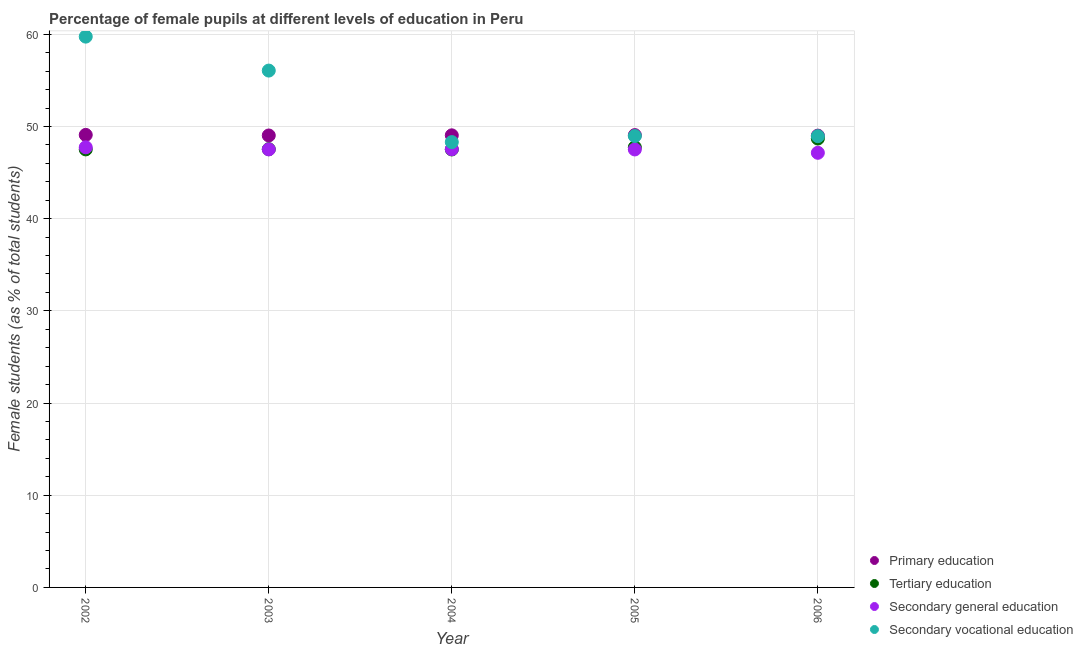What is the percentage of female students in secondary vocational education in 2004?
Give a very brief answer. 48.3. Across all years, what is the maximum percentage of female students in secondary vocational education?
Offer a terse response. 59.74. Across all years, what is the minimum percentage of female students in primary education?
Your answer should be very brief. 49. In which year was the percentage of female students in secondary education maximum?
Your answer should be very brief. 2002. In which year was the percentage of female students in tertiary education minimum?
Your answer should be very brief. 2004. What is the total percentage of female students in tertiary education in the graph?
Offer a terse response. 238.97. What is the difference between the percentage of female students in tertiary education in 2003 and that in 2005?
Ensure brevity in your answer.  -0.21. What is the difference between the percentage of female students in primary education in 2006 and the percentage of female students in secondary education in 2002?
Provide a succinct answer. 1.27. What is the average percentage of female students in secondary vocational education per year?
Offer a very short reply. 52.4. In the year 2004, what is the difference between the percentage of female students in primary education and percentage of female students in secondary vocational education?
Provide a short and direct response. 0.73. In how many years, is the percentage of female students in primary education greater than 22 %?
Your response must be concise. 5. What is the ratio of the percentage of female students in secondary vocational education in 2002 to that in 2003?
Your answer should be very brief. 1.07. What is the difference between the highest and the second highest percentage of female students in tertiary education?
Offer a very short reply. 0.95. What is the difference between the highest and the lowest percentage of female students in secondary vocational education?
Provide a short and direct response. 11.44. Is it the case that in every year, the sum of the percentage of female students in primary education and percentage of female students in secondary vocational education is greater than the sum of percentage of female students in secondary education and percentage of female students in tertiary education?
Give a very brief answer. No. Does the percentage of female students in primary education monotonically increase over the years?
Your response must be concise. No. How many years are there in the graph?
Your answer should be very brief. 5. What is the difference between two consecutive major ticks on the Y-axis?
Ensure brevity in your answer.  10. Does the graph contain grids?
Provide a short and direct response. Yes. Where does the legend appear in the graph?
Ensure brevity in your answer.  Bottom right. What is the title of the graph?
Your response must be concise. Percentage of female pupils at different levels of education in Peru. What is the label or title of the X-axis?
Make the answer very short. Year. What is the label or title of the Y-axis?
Your answer should be compact. Female students (as % of total students). What is the Female students (as % of total students) of Primary education in 2002?
Offer a terse response. 49.08. What is the Female students (as % of total students) of Tertiary education in 2002?
Your response must be concise. 47.51. What is the Female students (as % of total students) of Secondary general education in 2002?
Offer a terse response. 47.74. What is the Female students (as % of total students) in Secondary vocational education in 2002?
Offer a very short reply. 59.74. What is the Female students (as % of total students) of Primary education in 2003?
Your answer should be compact. 49.02. What is the Female students (as % of total students) of Tertiary education in 2003?
Ensure brevity in your answer.  47.53. What is the Female students (as % of total students) in Secondary general education in 2003?
Make the answer very short. 47.51. What is the Female students (as % of total students) in Secondary vocational education in 2003?
Offer a terse response. 56.06. What is the Female students (as % of total students) of Primary education in 2004?
Ensure brevity in your answer.  49.04. What is the Female students (as % of total students) of Tertiary education in 2004?
Offer a very short reply. 47.5. What is the Female students (as % of total students) of Secondary general education in 2004?
Provide a succinct answer. 47.53. What is the Female students (as % of total students) in Secondary vocational education in 2004?
Your answer should be compact. 48.3. What is the Female students (as % of total students) of Primary education in 2005?
Ensure brevity in your answer.  49.06. What is the Female students (as % of total students) in Tertiary education in 2005?
Your answer should be very brief. 47.74. What is the Female students (as % of total students) of Secondary general education in 2005?
Your response must be concise. 47.5. What is the Female students (as % of total students) in Secondary vocational education in 2005?
Your answer should be very brief. 48.96. What is the Female students (as % of total students) in Primary education in 2006?
Offer a very short reply. 49. What is the Female students (as % of total students) in Tertiary education in 2006?
Provide a short and direct response. 48.69. What is the Female students (as % of total students) in Secondary general education in 2006?
Offer a terse response. 47.14. What is the Female students (as % of total students) of Secondary vocational education in 2006?
Offer a very short reply. 48.94. Across all years, what is the maximum Female students (as % of total students) in Primary education?
Your response must be concise. 49.08. Across all years, what is the maximum Female students (as % of total students) in Tertiary education?
Provide a short and direct response. 48.69. Across all years, what is the maximum Female students (as % of total students) in Secondary general education?
Give a very brief answer. 47.74. Across all years, what is the maximum Female students (as % of total students) in Secondary vocational education?
Your response must be concise. 59.74. Across all years, what is the minimum Female students (as % of total students) of Primary education?
Your answer should be very brief. 49. Across all years, what is the minimum Female students (as % of total students) in Tertiary education?
Give a very brief answer. 47.5. Across all years, what is the minimum Female students (as % of total students) in Secondary general education?
Offer a very short reply. 47.14. Across all years, what is the minimum Female students (as % of total students) of Secondary vocational education?
Keep it short and to the point. 48.3. What is the total Female students (as % of total students) of Primary education in the graph?
Provide a succinct answer. 245.2. What is the total Female students (as % of total students) in Tertiary education in the graph?
Ensure brevity in your answer.  238.97. What is the total Female students (as % of total students) in Secondary general education in the graph?
Offer a terse response. 237.43. What is the total Female students (as % of total students) in Secondary vocational education in the graph?
Offer a very short reply. 262.01. What is the difference between the Female students (as % of total students) in Primary education in 2002 and that in 2003?
Your answer should be very brief. 0.06. What is the difference between the Female students (as % of total students) in Tertiary education in 2002 and that in 2003?
Offer a very short reply. -0.02. What is the difference between the Female students (as % of total students) of Secondary general education in 2002 and that in 2003?
Offer a terse response. 0.23. What is the difference between the Female students (as % of total students) in Secondary vocational education in 2002 and that in 2003?
Provide a short and direct response. 3.68. What is the difference between the Female students (as % of total students) in Primary education in 2002 and that in 2004?
Provide a short and direct response. 0.05. What is the difference between the Female students (as % of total students) in Tertiary education in 2002 and that in 2004?
Your answer should be compact. 0.01. What is the difference between the Female students (as % of total students) of Secondary general education in 2002 and that in 2004?
Your answer should be very brief. 0.21. What is the difference between the Female students (as % of total students) in Secondary vocational education in 2002 and that in 2004?
Your answer should be compact. 11.44. What is the difference between the Female students (as % of total students) of Primary education in 2002 and that in 2005?
Provide a short and direct response. 0.02. What is the difference between the Female students (as % of total students) in Tertiary education in 2002 and that in 2005?
Offer a very short reply. -0.23. What is the difference between the Female students (as % of total students) in Secondary general education in 2002 and that in 2005?
Make the answer very short. 0.23. What is the difference between the Female students (as % of total students) of Secondary vocational education in 2002 and that in 2005?
Make the answer very short. 10.78. What is the difference between the Female students (as % of total students) of Primary education in 2002 and that in 2006?
Keep it short and to the point. 0.08. What is the difference between the Female students (as % of total students) in Tertiary education in 2002 and that in 2006?
Offer a terse response. -1.18. What is the difference between the Female students (as % of total students) in Secondary general education in 2002 and that in 2006?
Your response must be concise. 0.6. What is the difference between the Female students (as % of total students) of Secondary vocational education in 2002 and that in 2006?
Provide a short and direct response. 10.8. What is the difference between the Female students (as % of total students) of Primary education in 2003 and that in 2004?
Your answer should be very brief. -0.02. What is the difference between the Female students (as % of total students) of Tertiary education in 2003 and that in 2004?
Give a very brief answer. 0.03. What is the difference between the Female students (as % of total students) in Secondary general education in 2003 and that in 2004?
Make the answer very short. -0.02. What is the difference between the Female students (as % of total students) of Secondary vocational education in 2003 and that in 2004?
Offer a terse response. 7.76. What is the difference between the Female students (as % of total students) of Primary education in 2003 and that in 2005?
Make the answer very short. -0.04. What is the difference between the Female students (as % of total students) in Tertiary education in 2003 and that in 2005?
Your answer should be very brief. -0.21. What is the difference between the Female students (as % of total students) of Secondary general education in 2003 and that in 2005?
Your answer should be very brief. 0.01. What is the difference between the Female students (as % of total students) in Secondary vocational education in 2003 and that in 2005?
Provide a succinct answer. 7.1. What is the difference between the Female students (as % of total students) of Primary education in 2003 and that in 2006?
Your response must be concise. 0.02. What is the difference between the Female students (as % of total students) in Tertiary education in 2003 and that in 2006?
Offer a very short reply. -1.16. What is the difference between the Female students (as % of total students) in Secondary general education in 2003 and that in 2006?
Offer a very short reply. 0.37. What is the difference between the Female students (as % of total students) of Secondary vocational education in 2003 and that in 2006?
Give a very brief answer. 7.12. What is the difference between the Female students (as % of total students) of Primary education in 2004 and that in 2005?
Offer a terse response. -0.02. What is the difference between the Female students (as % of total students) of Tertiary education in 2004 and that in 2005?
Your answer should be very brief. -0.23. What is the difference between the Female students (as % of total students) of Secondary general education in 2004 and that in 2005?
Your answer should be very brief. 0.03. What is the difference between the Female students (as % of total students) of Secondary vocational education in 2004 and that in 2005?
Your response must be concise. -0.66. What is the difference between the Female students (as % of total students) in Primary education in 2004 and that in 2006?
Offer a terse response. 0.03. What is the difference between the Female students (as % of total students) in Tertiary education in 2004 and that in 2006?
Provide a short and direct response. -1.18. What is the difference between the Female students (as % of total students) of Secondary general education in 2004 and that in 2006?
Provide a succinct answer. 0.39. What is the difference between the Female students (as % of total students) in Secondary vocational education in 2004 and that in 2006?
Make the answer very short. -0.64. What is the difference between the Female students (as % of total students) in Primary education in 2005 and that in 2006?
Offer a very short reply. 0.06. What is the difference between the Female students (as % of total students) of Tertiary education in 2005 and that in 2006?
Make the answer very short. -0.95. What is the difference between the Female students (as % of total students) in Secondary general education in 2005 and that in 2006?
Your answer should be very brief. 0.36. What is the difference between the Female students (as % of total students) of Secondary vocational education in 2005 and that in 2006?
Your response must be concise. 0.02. What is the difference between the Female students (as % of total students) in Primary education in 2002 and the Female students (as % of total students) in Tertiary education in 2003?
Offer a terse response. 1.55. What is the difference between the Female students (as % of total students) of Primary education in 2002 and the Female students (as % of total students) of Secondary general education in 2003?
Your answer should be very brief. 1.57. What is the difference between the Female students (as % of total students) of Primary education in 2002 and the Female students (as % of total students) of Secondary vocational education in 2003?
Provide a short and direct response. -6.98. What is the difference between the Female students (as % of total students) in Tertiary education in 2002 and the Female students (as % of total students) in Secondary vocational education in 2003?
Your answer should be very brief. -8.55. What is the difference between the Female students (as % of total students) in Secondary general education in 2002 and the Female students (as % of total students) in Secondary vocational education in 2003?
Ensure brevity in your answer.  -8.32. What is the difference between the Female students (as % of total students) of Primary education in 2002 and the Female students (as % of total students) of Tertiary education in 2004?
Your response must be concise. 1.58. What is the difference between the Female students (as % of total students) in Primary education in 2002 and the Female students (as % of total students) in Secondary general education in 2004?
Give a very brief answer. 1.55. What is the difference between the Female students (as % of total students) in Primary education in 2002 and the Female students (as % of total students) in Secondary vocational education in 2004?
Offer a very short reply. 0.78. What is the difference between the Female students (as % of total students) in Tertiary education in 2002 and the Female students (as % of total students) in Secondary general education in 2004?
Offer a terse response. -0.02. What is the difference between the Female students (as % of total students) of Tertiary education in 2002 and the Female students (as % of total students) of Secondary vocational education in 2004?
Provide a succinct answer. -0.79. What is the difference between the Female students (as % of total students) in Secondary general education in 2002 and the Female students (as % of total students) in Secondary vocational education in 2004?
Ensure brevity in your answer.  -0.56. What is the difference between the Female students (as % of total students) of Primary education in 2002 and the Female students (as % of total students) of Tertiary education in 2005?
Your answer should be very brief. 1.35. What is the difference between the Female students (as % of total students) in Primary education in 2002 and the Female students (as % of total students) in Secondary general education in 2005?
Your answer should be compact. 1.58. What is the difference between the Female students (as % of total students) of Primary education in 2002 and the Female students (as % of total students) of Secondary vocational education in 2005?
Your answer should be very brief. 0.12. What is the difference between the Female students (as % of total students) of Tertiary education in 2002 and the Female students (as % of total students) of Secondary general education in 2005?
Your answer should be compact. 0.01. What is the difference between the Female students (as % of total students) of Tertiary education in 2002 and the Female students (as % of total students) of Secondary vocational education in 2005?
Offer a terse response. -1.45. What is the difference between the Female students (as % of total students) of Secondary general education in 2002 and the Female students (as % of total students) of Secondary vocational education in 2005?
Offer a very short reply. -1.22. What is the difference between the Female students (as % of total students) in Primary education in 2002 and the Female students (as % of total students) in Tertiary education in 2006?
Keep it short and to the point. 0.4. What is the difference between the Female students (as % of total students) in Primary education in 2002 and the Female students (as % of total students) in Secondary general education in 2006?
Your answer should be very brief. 1.94. What is the difference between the Female students (as % of total students) in Primary education in 2002 and the Female students (as % of total students) in Secondary vocational education in 2006?
Offer a terse response. 0.14. What is the difference between the Female students (as % of total students) in Tertiary education in 2002 and the Female students (as % of total students) in Secondary general education in 2006?
Offer a very short reply. 0.37. What is the difference between the Female students (as % of total students) in Tertiary education in 2002 and the Female students (as % of total students) in Secondary vocational education in 2006?
Your answer should be compact. -1.43. What is the difference between the Female students (as % of total students) in Secondary general education in 2002 and the Female students (as % of total students) in Secondary vocational education in 2006?
Make the answer very short. -1.21. What is the difference between the Female students (as % of total students) in Primary education in 2003 and the Female students (as % of total students) in Tertiary education in 2004?
Provide a succinct answer. 1.52. What is the difference between the Female students (as % of total students) in Primary education in 2003 and the Female students (as % of total students) in Secondary general education in 2004?
Offer a very short reply. 1.49. What is the difference between the Female students (as % of total students) in Primary education in 2003 and the Female students (as % of total students) in Secondary vocational education in 2004?
Your answer should be very brief. 0.72. What is the difference between the Female students (as % of total students) in Tertiary education in 2003 and the Female students (as % of total students) in Secondary general education in 2004?
Provide a succinct answer. 0. What is the difference between the Female students (as % of total students) of Tertiary education in 2003 and the Female students (as % of total students) of Secondary vocational education in 2004?
Provide a succinct answer. -0.77. What is the difference between the Female students (as % of total students) in Secondary general education in 2003 and the Female students (as % of total students) in Secondary vocational education in 2004?
Provide a short and direct response. -0.79. What is the difference between the Female students (as % of total students) of Primary education in 2003 and the Female students (as % of total students) of Tertiary education in 2005?
Provide a short and direct response. 1.28. What is the difference between the Female students (as % of total students) in Primary education in 2003 and the Female students (as % of total students) in Secondary general education in 2005?
Give a very brief answer. 1.52. What is the difference between the Female students (as % of total students) in Primary education in 2003 and the Female students (as % of total students) in Secondary vocational education in 2005?
Ensure brevity in your answer.  0.06. What is the difference between the Female students (as % of total students) in Tertiary education in 2003 and the Female students (as % of total students) in Secondary general education in 2005?
Make the answer very short. 0.03. What is the difference between the Female students (as % of total students) of Tertiary education in 2003 and the Female students (as % of total students) of Secondary vocational education in 2005?
Your answer should be very brief. -1.43. What is the difference between the Female students (as % of total students) of Secondary general education in 2003 and the Female students (as % of total students) of Secondary vocational education in 2005?
Ensure brevity in your answer.  -1.45. What is the difference between the Female students (as % of total students) in Primary education in 2003 and the Female students (as % of total students) in Tertiary education in 2006?
Give a very brief answer. 0.33. What is the difference between the Female students (as % of total students) in Primary education in 2003 and the Female students (as % of total students) in Secondary general education in 2006?
Make the answer very short. 1.88. What is the difference between the Female students (as % of total students) in Primary education in 2003 and the Female students (as % of total students) in Secondary vocational education in 2006?
Offer a very short reply. 0.08. What is the difference between the Female students (as % of total students) in Tertiary education in 2003 and the Female students (as % of total students) in Secondary general education in 2006?
Offer a terse response. 0.39. What is the difference between the Female students (as % of total students) of Tertiary education in 2003 and the Female students (as % of total students) of Secondary vocational education in 2006?
Keep it short and to the point. -1.41. What is the difference between the Female students (as % of total students) of Secondary general education in 2003 and the Female students (as % of total students) of Secondary vocational education in 2006?
Keep it short and to the point. -1.43. What is the difference between the Female students (as % of total students) of Primary education in 2004 and the Female students (as % of total students) of Tertiary education in 2005?
Make the answer very short. 1.3. What is the difference between the Female students (as % of total students) of Primary education in 2004 and the Female students (as % of total students) of Secondary general education in 2005?
Provide a succinct answer. 1.53. What is the difference between the Female students (as % of total students) of Primary education in 2004 and the Female students (as % of total students) of Secondary vocational education in 2005?
Keep it short and to the point. 0.08. What is the difference between the Female students (as % of total students) of Tertiary education in 2004 and the Female students (as % of total students) of Secondary general education in 2005?
Keep it short and to the point. 0. What is the difference between the Female students (as % of total students) of Tertiary education in 2004 and the Female students (as % of total students) of Secondary vocational education in 2005?
Your answer should be very brief. -1.46. What is the difference between the Female students (as % of total students) of Secondary general education in 2004 and the Female students (as % of total students) of Secondary vocational education in 2005?
Make the answer very short. -1.43. What is the difference between the Female students (as % of total students) in Primary education in 2004 and the Female students (as % of total students) in Tertiary education in 2006?
Ensure brevity in your answer.  0.35. What is the difference between the Female students (as % of total students) of Primary education in 2004 and the Female students (as % of total students) of Secondary general education in 2006?
Provide a short and direct response. 1.89. What is the difference between the Female students (as % of total students) of Primary education in 2004 and the Female students (as % of total students) of Secondary vocational education in 2006?
Your response must be concise. 0.09. What is the difference between the Female students (as % of total students) of Tertiary education in 2004 and the Female students (as % of total students) of Secondary general education in 2006?
Provide a short and direct response. 0.36. What is the difference between the Female students (as % of total students) of Tertiary education in 2004 and the Female students (as % of total students) of Secondary vocational education in 2006?
Give a very brief answer. -1.44. What is the difference between the Female students (as % of total students) of Secondary general education in 2004 and the Female students (as % of total students) of Secondary vocational education in 2006?
Keep it short and to the point. -1.41. What is the difference between the Female students (as % of total students) of Primary education in 2005 and the Female students (as % of total students) of Tertiary education in 2006?
Your response must be concise. 0.37. What is the difference between the Female students (as % of total students) of Primary education in 2005 and the Female students (as % of total students) of Secondary general education in 2006?
Offer a very short reply. 1.92. What is the difference between the Female students (as % of total students) in Primary education in 2005 and the Female students (as % of total students) in Secondary vocational education in 2006?
Your answer should be compact. 0.12. What is the difference between the Female students (as % of total students) in Tertiary education in 2005 and the Female students (as % of total students) in Secondary general education in 2006?
Ensure brevity in your answer.  0.6. What is the difference between the Female students (as % of total students) in Tertiary education in 2005 and the Female students (as % of total students) in Secondary vocational education in 2006?
Ensure brevity in your answer.  -1.21. What is the difference between the Female students (as % of total students) of Secondary general education in 2005 and the Female students (as % of total students) of Secondary vocational education in 2006?
Offer a very short reply. -1.44. What is the average Female students (as % of total students) in Primary education per year?
Your answer should be very brief. 49.04. What is the average Female students (as % of total students) of Tertiary education per year?
Give a very brief answer. 47.79. What is the average Female students (as % of total students) in Secondary general education per year?
Keep it short and to the point. 47.49. What is the average Female students (as % of total students) in Secondary vocational education per year?
Keep it short and to the point. 52.4. In the year 2002, what is the difference between the Female students (as % of total students) of Primary education and Female students (as % of total students) of Tertiary education?
Your response must be concise. 1.57. In the year 2002, what is the difference between the Female students (as % of total students) in Primary education and Female students (as % of total students) in Secondary general education?
Provide a succinct answer. 1.35. In the year 2002, what is the difference between the Female students (as % of total students) of Primary education and Female students (as % of total students) of Secondary vocational education?
Offer a very short reply. -10.66. In the year 2002, what is the difference between the Female students (as % of total students) of Tertiary education and Female students (as % of total students) of Secondary general education?
Make the answer very short. -0.23. In the year 2002, what is the difference between the Female students (as % of total students) of Tertiary education and Female students (as % of total students) of Secondary vocational education?
Offer a very short reply. -12.23. In the year 2002, what is the difference between the Female students (as % of total students) in Secondary general education and Female students (as % of total students) in Secondary vocational education?
Offer a terse response. -12. In the year 2003, what is the difference between the Female students (as % of total students) of Primary education and Female students (as % of total students) of Tertiary education?
Your answer should be very brief. 1.49. In the year 2003, what is the difference between the Female students (as % of total students) of Primary education and Female students (as % of total students) of Secondary general education?
Give a very brief answer. 1.51. In the year 2003, what is the difference between the Female students (as % of total students) in Primary education and Female students (as % of total students) in Secondary vocational education?
Ensure brevity in your answer.  -7.04. In the year 2003, what is the difference between the Female students (as % of total students) in Tertiary education and Female students (as % of total students) in Secondary general education?
Your response must be concise. 0.02. In the year 2003, what is the difference between the Female students (as % of total students) of Tertiary education and Female students (as % of total students) of Secondary vocational education?
Keep it short and to the point. -8.53. In the year 2003, what is the difference between the Female students (as % of total students) in Secondary general education and Female students (as % of total students) in Secondary vocational education?
Provide a short and direct response. -8.55. In the year 2004, what is the difference between the Female students (as % of total students) of Primary education and Female students (as % of total students) of Tertiary education?
Ensure brevity in your answer.  1.53. In the year 2004, what is the difference between the Female students (as % of total students) in Primary education and Female students (as % of total students) in Secondary general education?
Your answer should be very brief. 1.5. In the year 2004, what is the difference between the Female students (as % of total students) of Primary education and Female students (as % of total students) of Secondary vocational education?
Offer a very short reply. 0.73. In the year 2004, what is the difference between the Female students (as % of total students) in Tertiary education and Female students (as % of total students) in Secondary general education?
Your answer should be compact. -0.03. In the year 2004, what is the difference between the Female students (as % of total students) in Tertiary education and Female students (as % of total students) in Secondary vocational education?
Ensure brevity in your answer.  -0.8. In the year 2004, what is the difference between the Female students (as % of total students) of Secondary general education and Female students (as % of total students) of Secondary vocational education?
Give a very brief answer. -0.77. In the year 2005, what is the difference between the Female students (as % of total students) in Primary education and Female students (as % of total students) in Tertiary education?
Offer a very short reply. 1.32. In the year 2005, what is the difference between the Female students (as % of total students) in Primary education and Female students (as % of total students) in Secondary general education?
Offer a very short reply. 1.56. In the year 2005, what is the difference between the Female students (as % of total students) of Primary education and Female students (as % of total students) of Secondary vocational education?
Your answer should be very brief. 0.1. In the year 2005, what is the difference between the Female students (as % of total students) in Tertiary education and Female students (as % of total students) in Secondary general education?
Provide a succinct answer. 0.23. In the year 2005, what is the difference between the Female students (as % of total students) in Tertiary education and Female students (as % of total students) in Secondary vocational education?
Provide a succinct answer. -1.22. In the year 2005, what is the difference between the Female students (as % of total students) in Secondary general education and Female students (as % of total students) in Secondary vocational education?
Your response must be concise. -1.46. In the year 2006, what is the difference between the Female students (as % of total students) of Primary education and Female students (as % of total students) of Tertiary education?
Offer a terse response. 0.32. In the year 2006, what is the difference between the Female students (as % of total students) in Primary education and Female students (as % of total students) in Secondary general education?
Make the answer very short. 1.86. In the year 2006, what is the difference between the Female students (as % of total students) of Primary education and Female students (as % of total students) of Secondary vocational education?
Your answer should be very brief. 0.06. In the year 2006, what is the difference between the Female students (as % of total students) of Tertiary education and Female students (as % of total students) of Secondary general education?
Make the answer very short. 1.55. In the year 2006, what is the difference between the Female students (as % of total students) of Tertiary education and Female students (as % of total students) of Secondary vocational education?
Give a very brief answer. -0.25. In the year 2006, what is the difference between the Female students (as % of total students) in Secondary general education and Female students (as % of total students) in Secondary vocational education?
Provide a succinct answer. -1.8. What is the ratio of the Female students (as % of total students) in Secondary general education in 2002 to that in 2003?
Your response must be concise. 1. What is the ratio of the Female students (as % of total students) of Secondary vocational education in 2002 to that in 2003?
Make the answer very short. 1.07. What is the ratio of the Female students (as % of total students) of Tertiary education in 2002 to that in 2004?
Your answer should be compact. 1. What is the ratio of the Female students (as % of total students) of Secondary general education in 2002 to that in 2004?
Your answer should be compact. 1. What is the ratio of the Female students (as % of total students) in Secondary vocational education in 2002 to that in 2004?
Your answer should be very brief. 1.24. What is the ratio of the Female students (as % of total students) of Primary education in 2002 to that in 2005?
Offer a very short reply. 1. What is the ratio of the Female students (as % of total students) in Tertiary education in 2002 to that in 2005?
Give a very brief answer. 1. What is the ratio of the Female students (as % of total students) of Secondary vocational education in 2002 to that in 2005?
Provide a short and direct response. 1.22. What is the ratio of the Female students (as % of total students) in Tertiary education in 2002 to that in 2006?
Give a very brief answer. 0.98. What is the ratio of the Female students (as % of total students) of Secondary general education in 2002 to that in 2006?
Make the answer very short. 1.01. What is the ratio of the Female students (as % of total students) of Secondary vocational education in 2002 to that in 2006?
Offer a very short reply. 1.22. What is the ratio of the Female students (as % of total students) of Primary education in 2003 to that in 2004?
Your response must be concise. 1. What is the ratio of the Female students (as % of total students) in Tertiary education in 2003 to that in 2004?
Provide a short and direct response. 1. What is the ratio of the Female students (as % of total students) of Secondary vocational education in 2003 to that in 2004?
Keep it short and to the point. 1.16. What is the ratio of the Female students (as % of total students) of Secondary general education in 2003 to that in 2005?
Provide a succinct answer. 1. What is the ratio of the Female students (as % of total students) in Secondary vocational education in 2003 to that in 2005?
Provide a short and direct response. 1.15. What is the ratio of the Female students (as % of total students) of Primary education in 2003 to that in 2006?
Provide a succinct answer. 1. What is the ratio of the Female students (as % of total students) of Tertiary education in 2003 to that in 2006?
Your answer should be compact. 0.98. What is the ratio of the Female students (as % of total students) of Secondary general education in 2003 to that in 2006?
Your response must be concise. 1.01. What is the ratio of the Female students (as % of total students) of Secondary vocational education in 2003 to that in 2006?
Provide a short and direct response. 1.15. What is the ratio of the Female students (as % of total students) in Primary education in 2004 to that in 2005?
Offer a very short reply. 1. What is the ratio of the Female students (as % of total students) of Tertiary education in 2004 to that in 2005?
Provide a short and direct response. 1. What is the ratio of the Female students (as % of total students) in Secondary vocational education in 2004 to that in 2005?
Keep it short and to the point. 0.99. What is the ratio of the Female students (as % of total students) of Primary education in 2004 to that in 2006?
Keep it short and to the point. 1. What is the ratio of the Female students (as % of total students) in Tertiary education in 2004 to that in 2006?
Offer a very short reply. 0.98. What is the ratio of the Female students (as % of total students) in Secondary general education in 2004 to that in 2006?
Ensure brevity in your answer.  1.01. What is the ratio of the Female students (as % of total students) in Secondary vocational education in 2004 to that in 2006?
Keep it short and to the point. 0.99. What is the ratio of the Female students (as % of total students) of Primary education in 2005 to that in 2006?
Offer a very short reply. 1. What is the ratio of the Female students (as % of total students) of Tertiary education in 2005 to that in 2006?
Keep it short and to the point. 0.98. What is the ratio of the Female students (as % of total students) in Secondary general education in 2005 to that in 2006?
Ensure brevity in your answer.  1.01. What is the difference between the highest and the second highest Female students (as % of total students) in Primary education?
Give a very brief answer. 0.02. What is the difference between the highest and the second highest Female students (as % of total students) of Tertiary education?
Provide a short and direct response. 0.95. What is the difference between the highest and the second highest Female students (as % of total students) in Secondary general education?
Your response must be concise. 0.21. What is the difference between the highest and the second highest Female students (as % of total students) of Secondary vocational education?
Give a very brief answer. 3.68. What is the difference between the highest and the lowest Female students (as % of total students) of Primary education?
Make the answer very short. 0.08. What is the difference between the highest and the lowest Female students (as % of total students) of Tertiary education?
Your answer should be very brief. 1.18. What is the difference between the highest and the lowest Female students (as % of total students) in Secondary general education?
Your response must be concise. 0.6. What is the difference between the highest and the lowest Female students (as % of total students) in Secondary vocational education?
Keep it short and to the point. 11.44. 